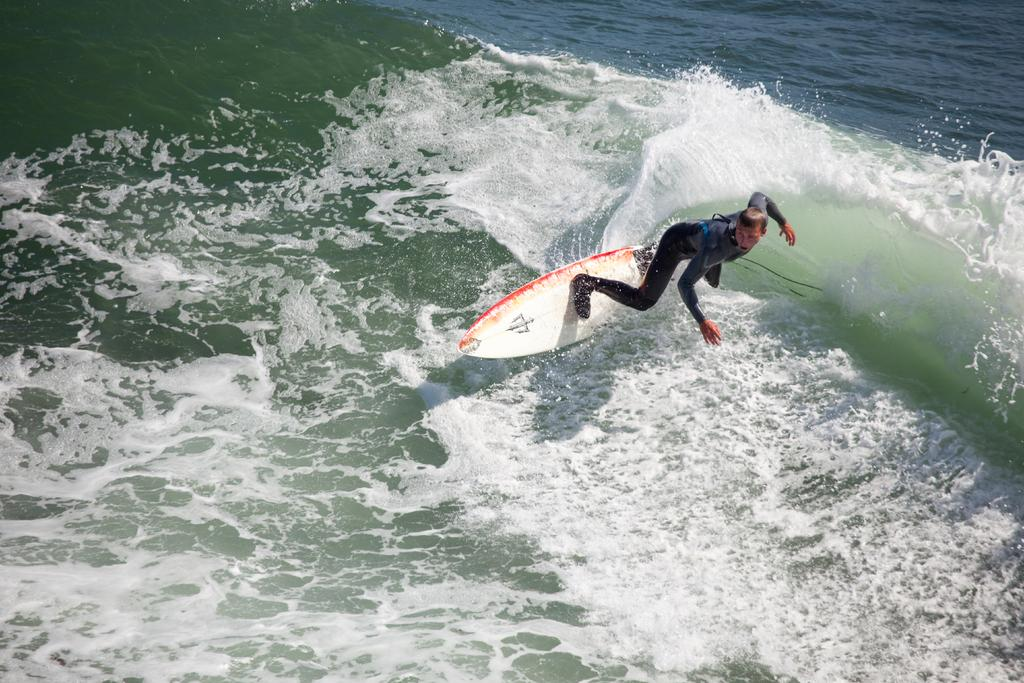What is present in the image besides the person? There is water visible in the image. What is the person wearing in the image? The person is wearing a black dress in the image. What activity is the person engaged in? The person is surfing on a board in the water. What type of muscle is being exercised by the person while surfing in the image? The image does not provide information about the person's muscles or any exercise they might be doing. What insurance policy does the person have while surfing in the image? The image does not provide information about the person's insurance or any policies they might have. 